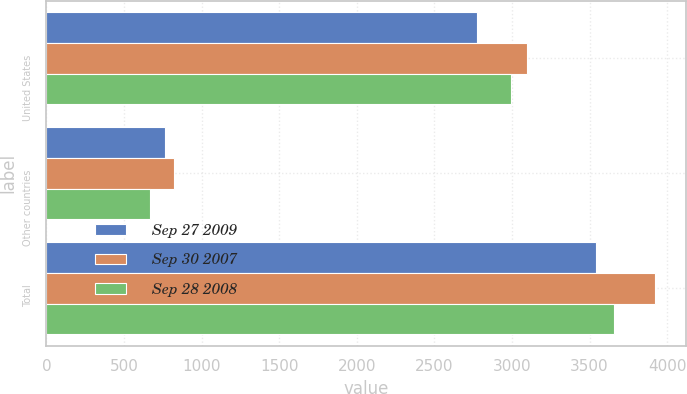<chart> <loc_0><loc_0><loc_500><loc_500><stacked_bar_chart><ecel><fcel>United States<fcel>Other countries<fcel>Total<nl><fcel>Sep 27 2009<fcel>2776.7<fcel>764.3<fcel>3541<nl><fcel>Sep 30 2007<fcel>3099.9<fcel>824.8<fcel>3924.7<nl><fcel>Sep 28 2008<fcel>2990.6<fcel>667.9<fcel>3658.5<nl></chart> 